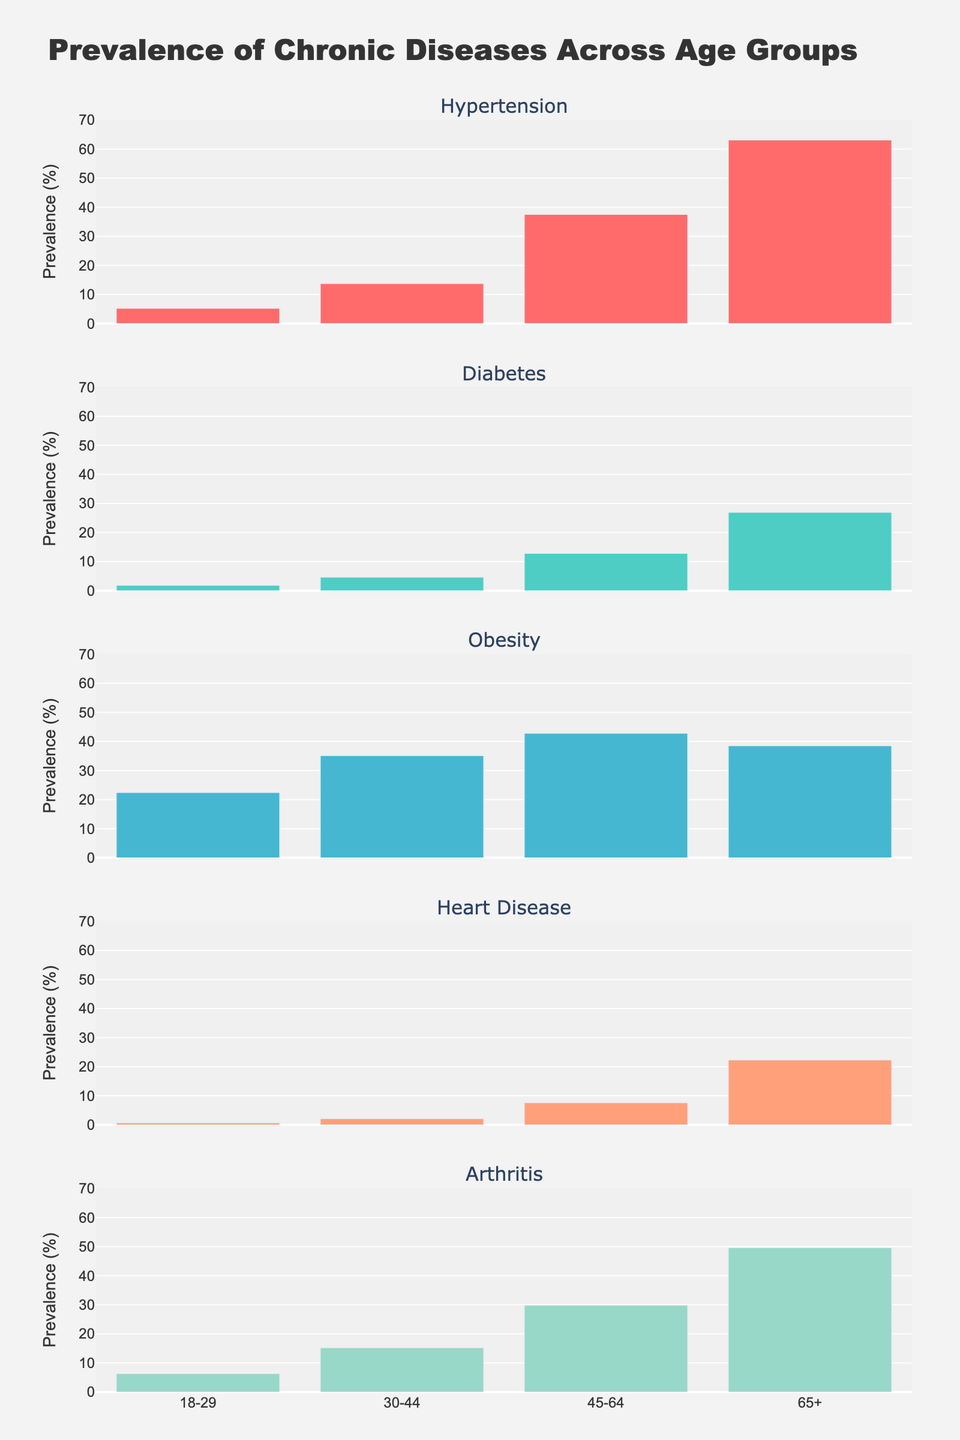How does the total funding for biodiversity conservation projects in North America change from 2018 to 2022? By examining the bars representing North America for each year, we see a progressive increase from $1200 million in 2018 to $1750 million in 2022.
Answer: Increased from $1200 million to $1750 million Which continent has the highest funding in 2022? By checking the height of the bars for each continent in 2022, Europe has the tallest bar, signifying the highest funding.
Answer: Europe Compare the funding allocations for biodiversity conservation projects between North America and South America in 2019. Which is higher and by how much? North America has $1350 million and South America has $900 million. Subtracting these gives a difference of $450 million in favor of North America.
Answer: North America by $450 million What is the average annual funding allocation for Asia from 2018 to 2022? The annual funding amounts are $900 million, $1050 million, $1200 million, $1400 million, and $1600 million. Summing these gives $6150 million. Dividing by 5 (the number of years) gives an average of $1230 million.
Answer: $1230 million How does funding in Oceania change from 2018 to 2019, and from 2021 to 2022? From 2018 to 2019, funding increases from $400 million to $450 million. From 2021 to 2022, it increases from $550 million to $600 million. Both intervals show an increase of $50 million.
Answer: Increased by $50 million (both periods) Which continent shows the largest absolute increase in funding from 2018 to 2022? By calculating the differences for each continent, Europe increases from $1500 million to $2200 million ($700 million), North America from $1200 million to $1750 million ($550 million), Asia from $900 million to $1600 million ($700 million), Africa from $600 million to $1100 million ($500 million), South America from $800 million to $1300 million ($500 million), and Oceania from $400 million to $600 million ($200 million). Europe and Asia have the largest increase of $700 million each.
Answer: Europe and Asia ($700 million) Identify the continent with the smallest funding allocation in 2020. Looking at the bars for 2020, Oceania has the shortest bar, indicating the smallest funding amount of $500 million.
Answer: Oceania What is the total funding allocation for biodiversity conservation projects across all continents in 2021? Adding the funding amounts for each continent in 2021: North America ($1600 million), Europe ($2000 million), Asia ($1400 million), Africa ($950 million), South America ($1150 million), and Oceania ($550 million). The sum is $7650 million.
Answer: $7650 million What trend can be observed in the funding allocation for biodiversity conservation projects in Africa from 2018 to 2022? Each subsequent year's bar is taller, indicating a consistent increase from $600 million in 2018 to $1100 million in 2022.
Answer: Increasing trend How does the continent with the second-highest funding allocation in 2020 compare to the one with the highest in the same year? Europe has the highest funding in 2020 with $1800 million, and North America follows with $1450 million. The difference is $350 million.
Answer: $350 million 